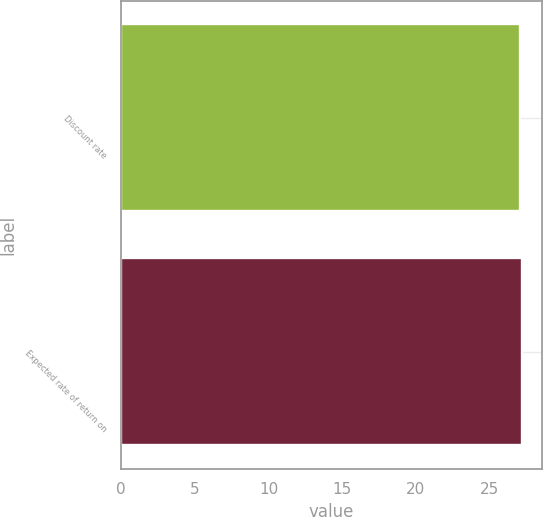Convert chart. <chart><loc_0><loc_0><loc_500><loc_500><bar_chart><fcel>Discount rate<fcel>Expected rate of return on<nl><fcel>27.1<fcel>27.2<nl></chart> 